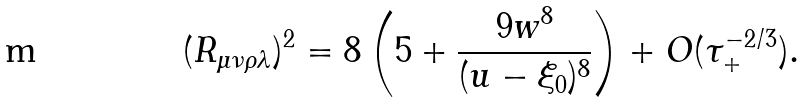Convert formula to latex. <formula><loc_0><loc_0><loc_500><loc_500>( R _ { \mu \nu \rho \lambda } ) ^ { 2 } = 8 \left ( 5 + \frac { 9 w ^ { 8 } } { ( u - \xi _ { 0 } ) ^ { 8 } } \right ) + O ( \tau _ { + } ^ { - 2 / 3 } ) .</formula> 